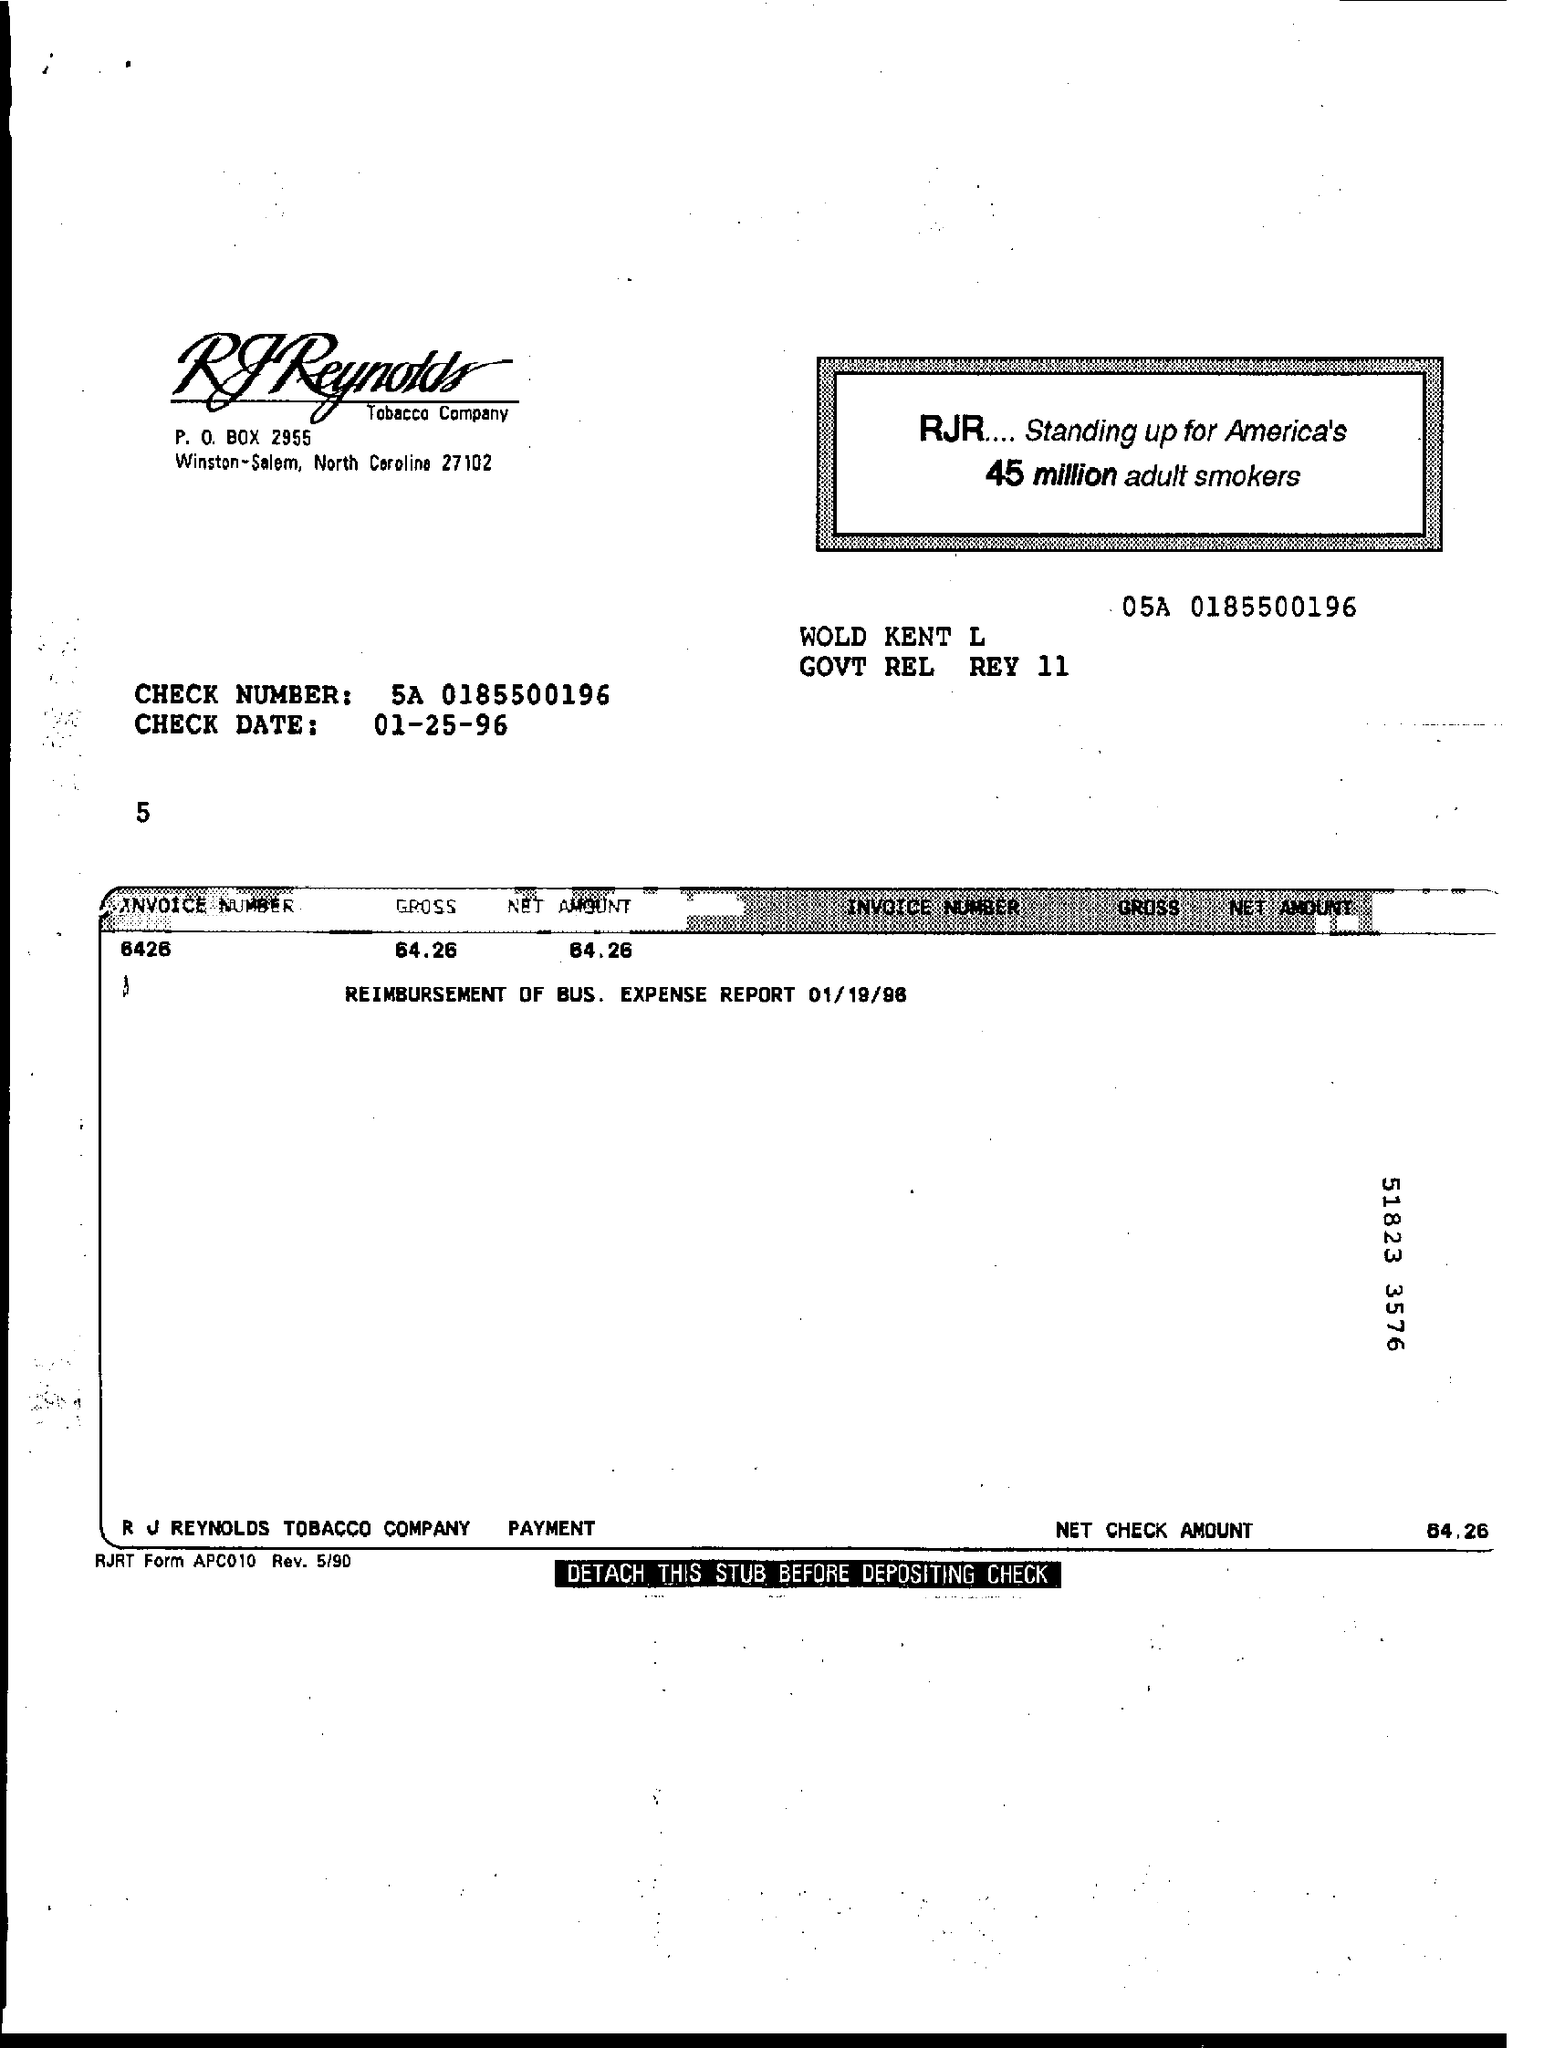What is the Check Number?
Provide a short and direct response. 5A 0185500196. What is the Check Date?
Offer a terse response. 01-25-96. What is the P.O. Box?
Your response must be concise. 2955. What is the Invoice Number?
Make the answer very short. 6426. What is the Gross?
Keep it short and to the point. 64.26. What is the Net Amount?
Provide a short and direct response. 64.26. What is the Net Check Amount?
Ensure brevity in your answer.  64.26. 